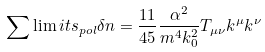<formula> <loc_0><loc_0><loc_500><loc_500>\sum \lim i t s _ { p o l } \delta n = \frac { 1 1 } { 4 5 } \frac { \alpha ^ { 2 } } { m ^ { 4 } k _ { 0 } ^ { 2 } } T _ { \mu \nu } k ^ { \mu } k ^ { \nu }</formula> 